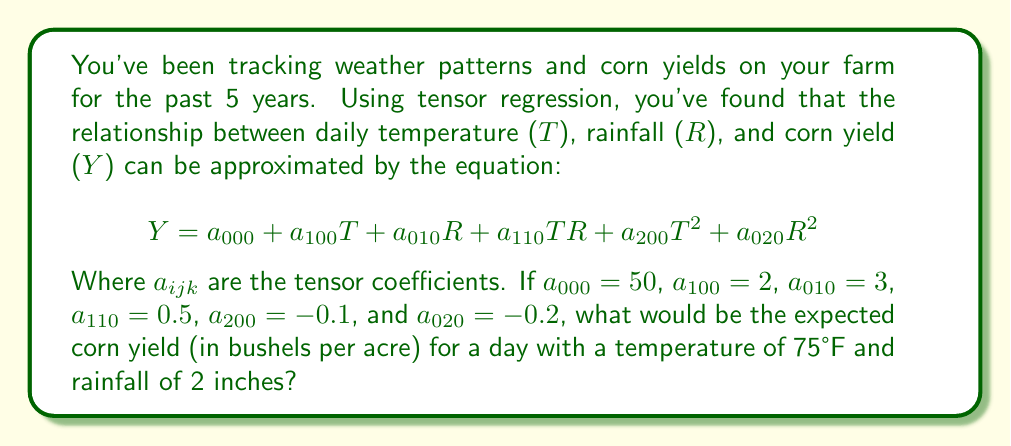Give your solution to this math problem. Let's approach this step-by-step:

1) We're given the tensor regression equation:
   $$Y = a_{000} + a_{100}T + a_{010}R + a_{110}TR + a_{200}T^2 + a_{020}R^2$$

2) We're also given the values for each coefficient:
   $a_{000} = 50$
   $a_{100} = 2$
   $a_{010} = 3$
   $a_{110} = 0.5$
   $a_{200} = -0.1$
   $a_{020} = -0.2$

3) We need to calculate Y for T = 75 (temperature in °F) and R = 2 (rainfall in inches).

4) Let's substitute these values into our equation:

   $$Y = 50 + 2(75) + 3(2) + 0.5(75)(2) + (-0.1)(75)^2 + (-0.2)(2)^2$$

5) Now, let's calculate each term:
   - $50$ (constant term)
   - $2(75) = 150$
   - $3(2) = 6$
   - $0.5(75)(2) = 75$
   - $(-0.1)(75)^2 = -0.1(5625) = -562.5$
   - $(-0.2)(2)^2 = -0.2(4) = -0.8$

6) Adding all these terms:
   $$Y = 50 + 150 + 6 + 75 - 562.5 - 0.8$$

7) Simplifying:
   $$Y = -282.3$$

Therefore, the expected corn yield would be -282.3 bushels per acre.

8) However, as a farmer, you know that negative yield doesn't make sense in reality. This result suggests that the conditions (75°F and 2 inches of rain) are extremely unfavorable for corn growth according to this model, possibly indicating a drought or heat stress situation.
Answer: -282.3 bushels per acre 